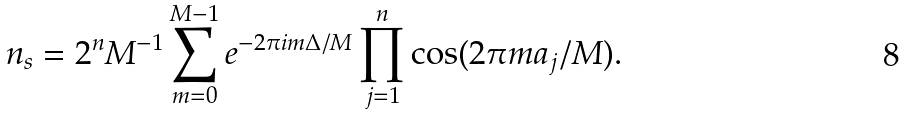<formula> <loc_0><loc_0><loc_500><loc_500>n _ { s } = 2 ^ { n } M ^ { - 1 } \sum _ { m = 0 } ^ { M - 1 } e ^ { - 2 \pi i m \Delta / M } \prod _ { j = 1 } ^ { n } \cos ( 2 \pi m a _ { j } / M ) .</formula> 